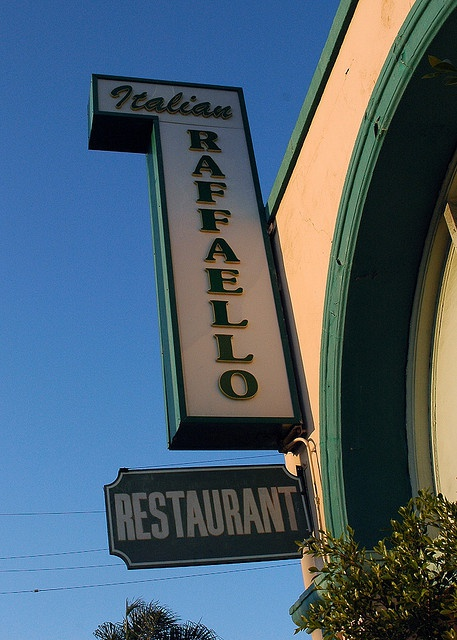Describe the objects in this image and their specific colors. I can see a potted plant in blue, black, olive, and gray tones in this image. 